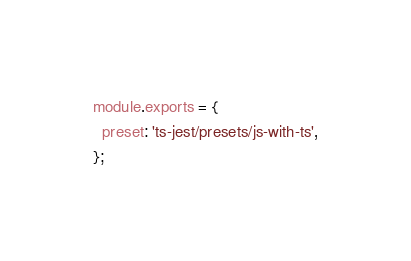<code> <loc_0><loc_0><loc_500><loc_500><_JavaScript_>module.exports = {
  preset: 'ts-jest/presets/js-with-ts',
};</code> 